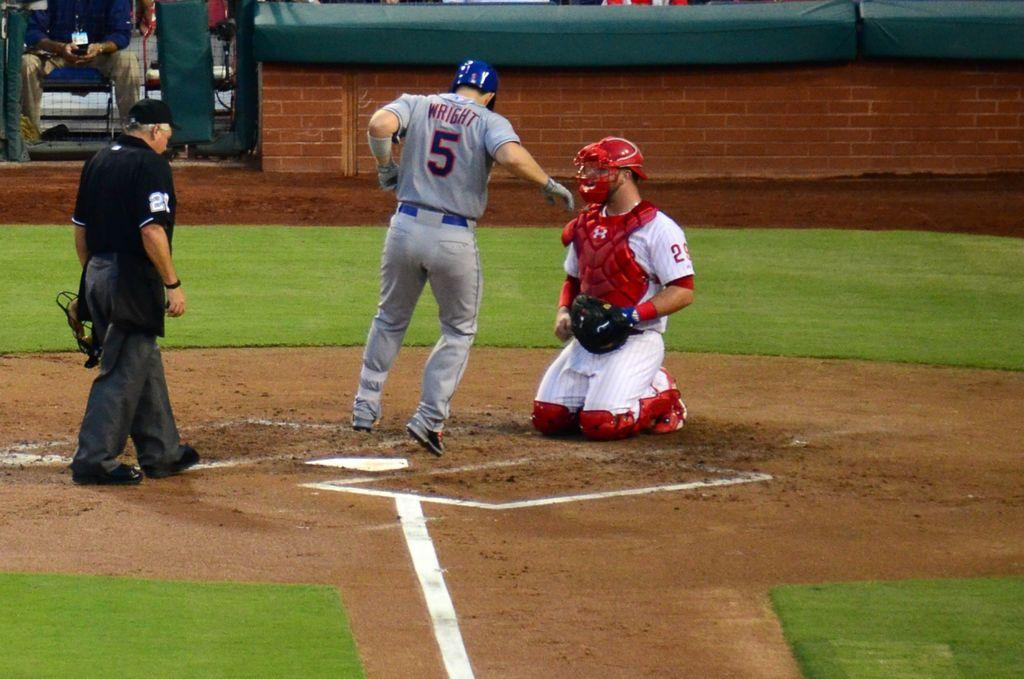<image>
Summarize the visual content of the image. A baseball player with the name Wright and Number 5 on his back is crossing home plate while the catcher looks on. 